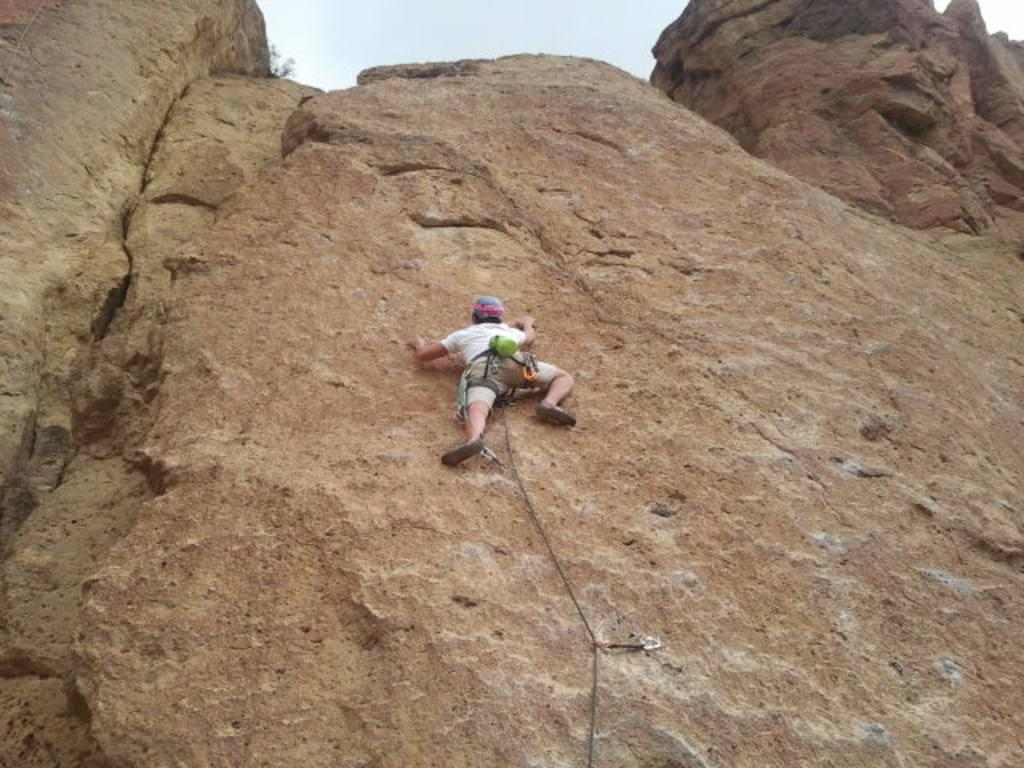What is the main subject of the image? There is a person in the image. What is the person doing in the image? The person is climbing a rock. What can be seen in the background of the image? The sky is visible in the background of the image. What type of music is the band playing in the image? There is no band present in the image, so it is not possible to determine what type of music they might be playing. 